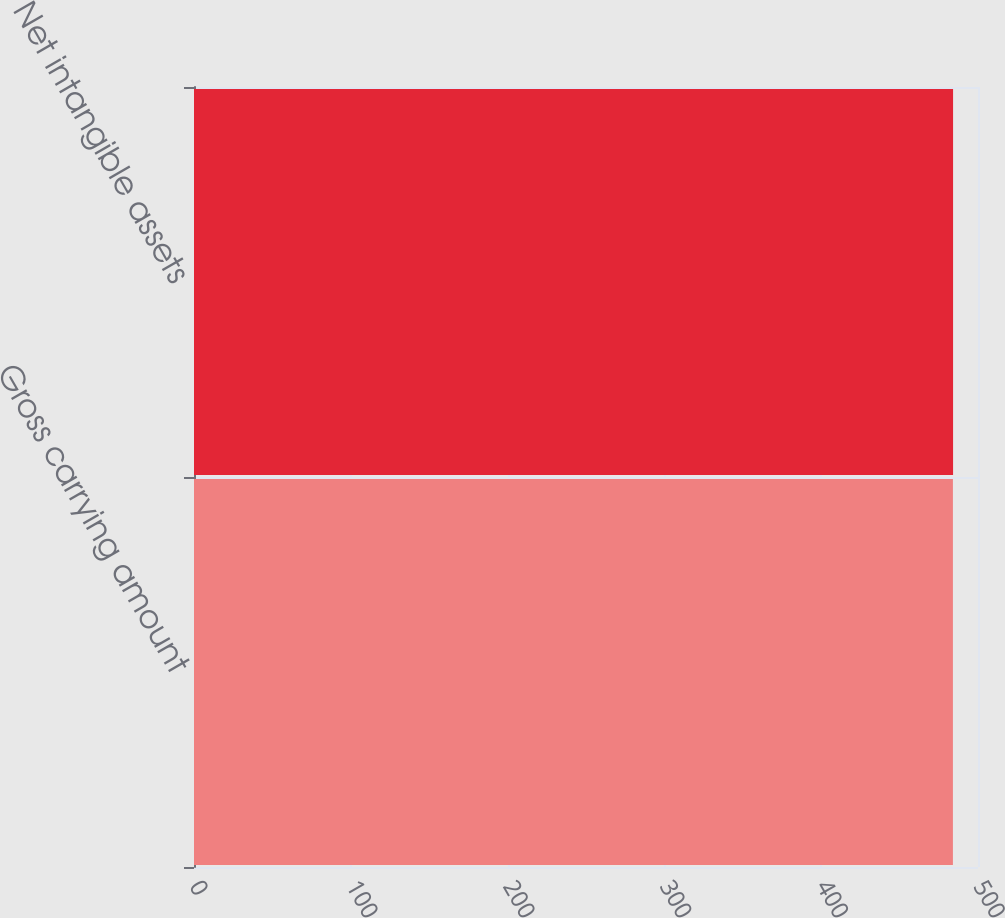Convert chart. <chart><loc_0><loc_0><loc_500><loc_500><bar_chart><fcel>Gross carrying amount<fcel>Net intangible assets<nl><fcel>484<fcel>484.1<nl></chart> 